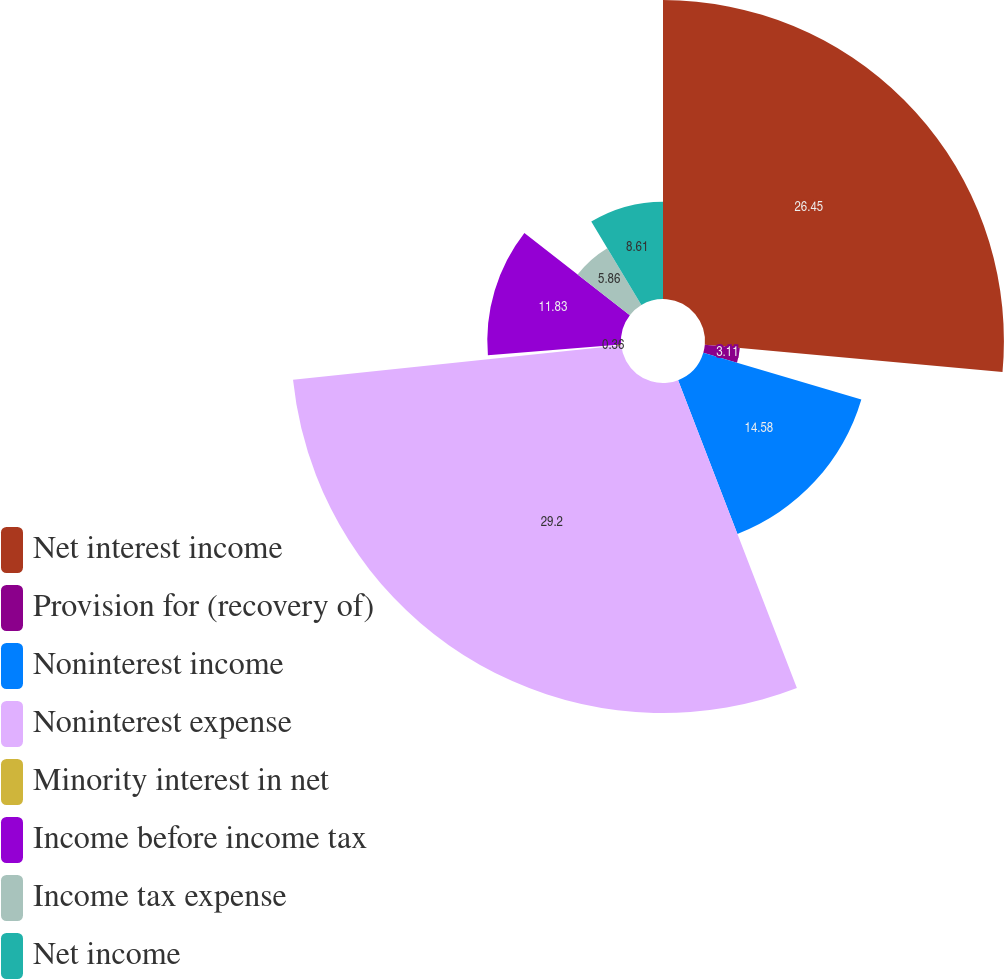<chart> <loc_0><loc_0><loc_500><loc_500><pie_chart><fcel>Net interest income<fcel>Provision for (recovery of)<fcel>Noninterest income<fcel>Noninterest expense<fcel>Minority interest in net<fcel>Income before income tax<fcel>Income tax expense<fcel>Net income<nl><fcel>26.45%<fcel>3.11%<fcel>14.58%<fcel>29.2%<fcel>0.36%<fcel>11.83%<fcel>5.86%<fcel>8.61%<nl></chart> 